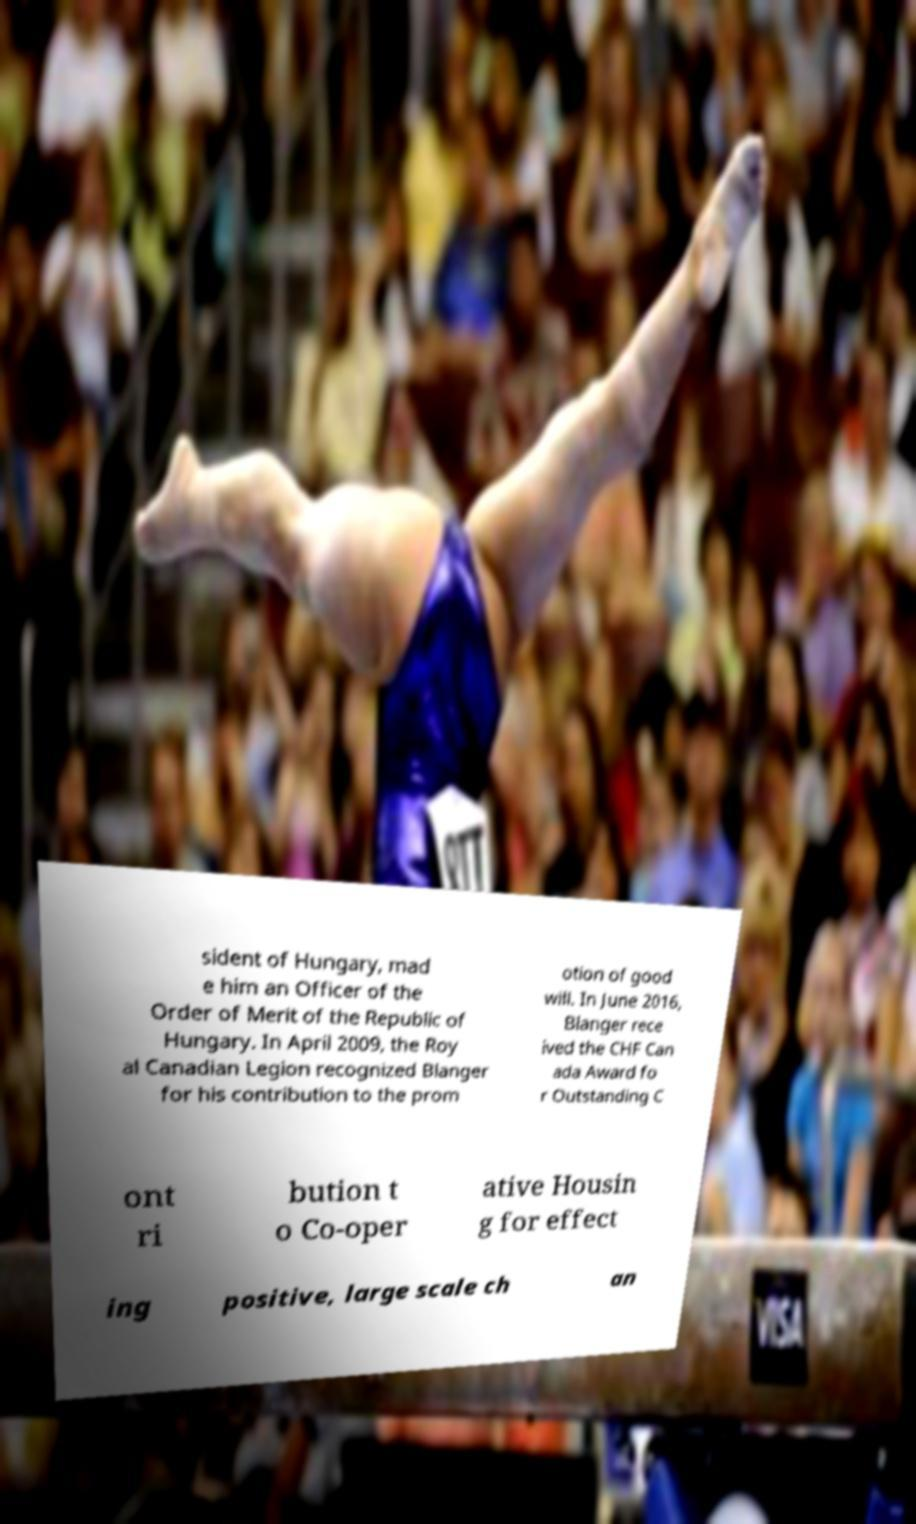Can you accurately transcribe the text from the provided image for me? sident of Hungary, mad e him an Officer of the Order of Merit of the Republic of Hungary. In April 2009, the Roy al Canadian Legion recognized Blanger for his contribution to the prom otion of good will. In June 2016, Blanger rece ived the CHF Can ada Award fo r Outstanding C ont ri bution t o Co-oper ative Housin g for effect ing positive, large scale ch an 